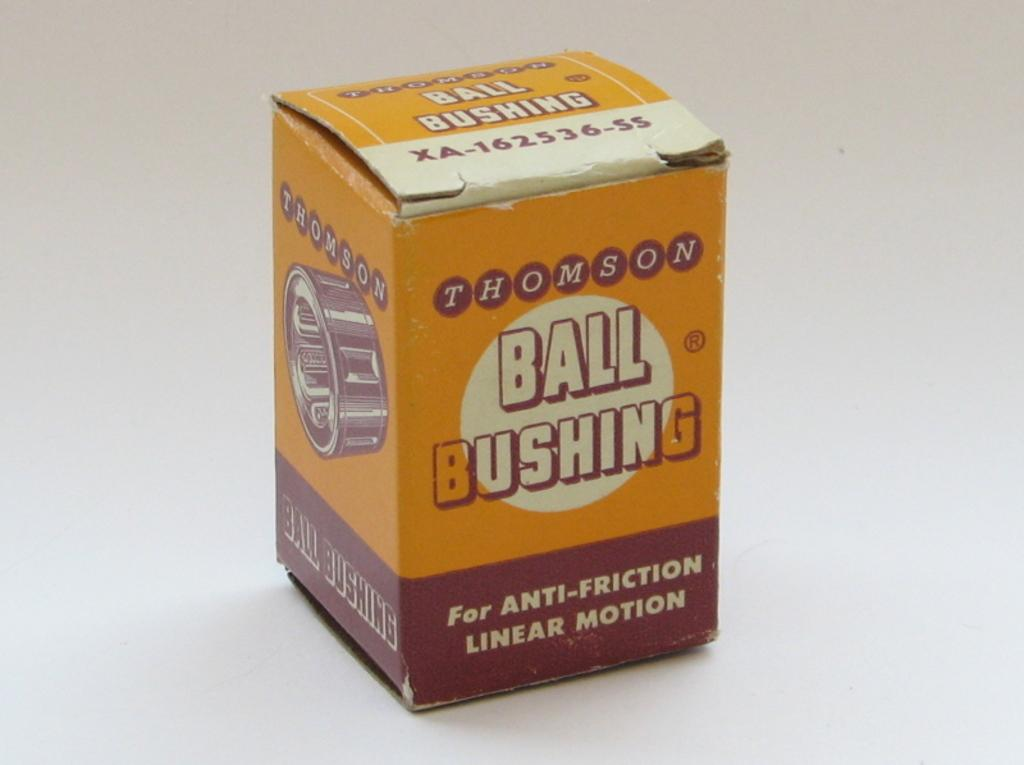<image>
Relay a brief, clear account of the picture shown. Vintage yellow box with title Thomson and Ball Bushing for anit-friction linear motion. 